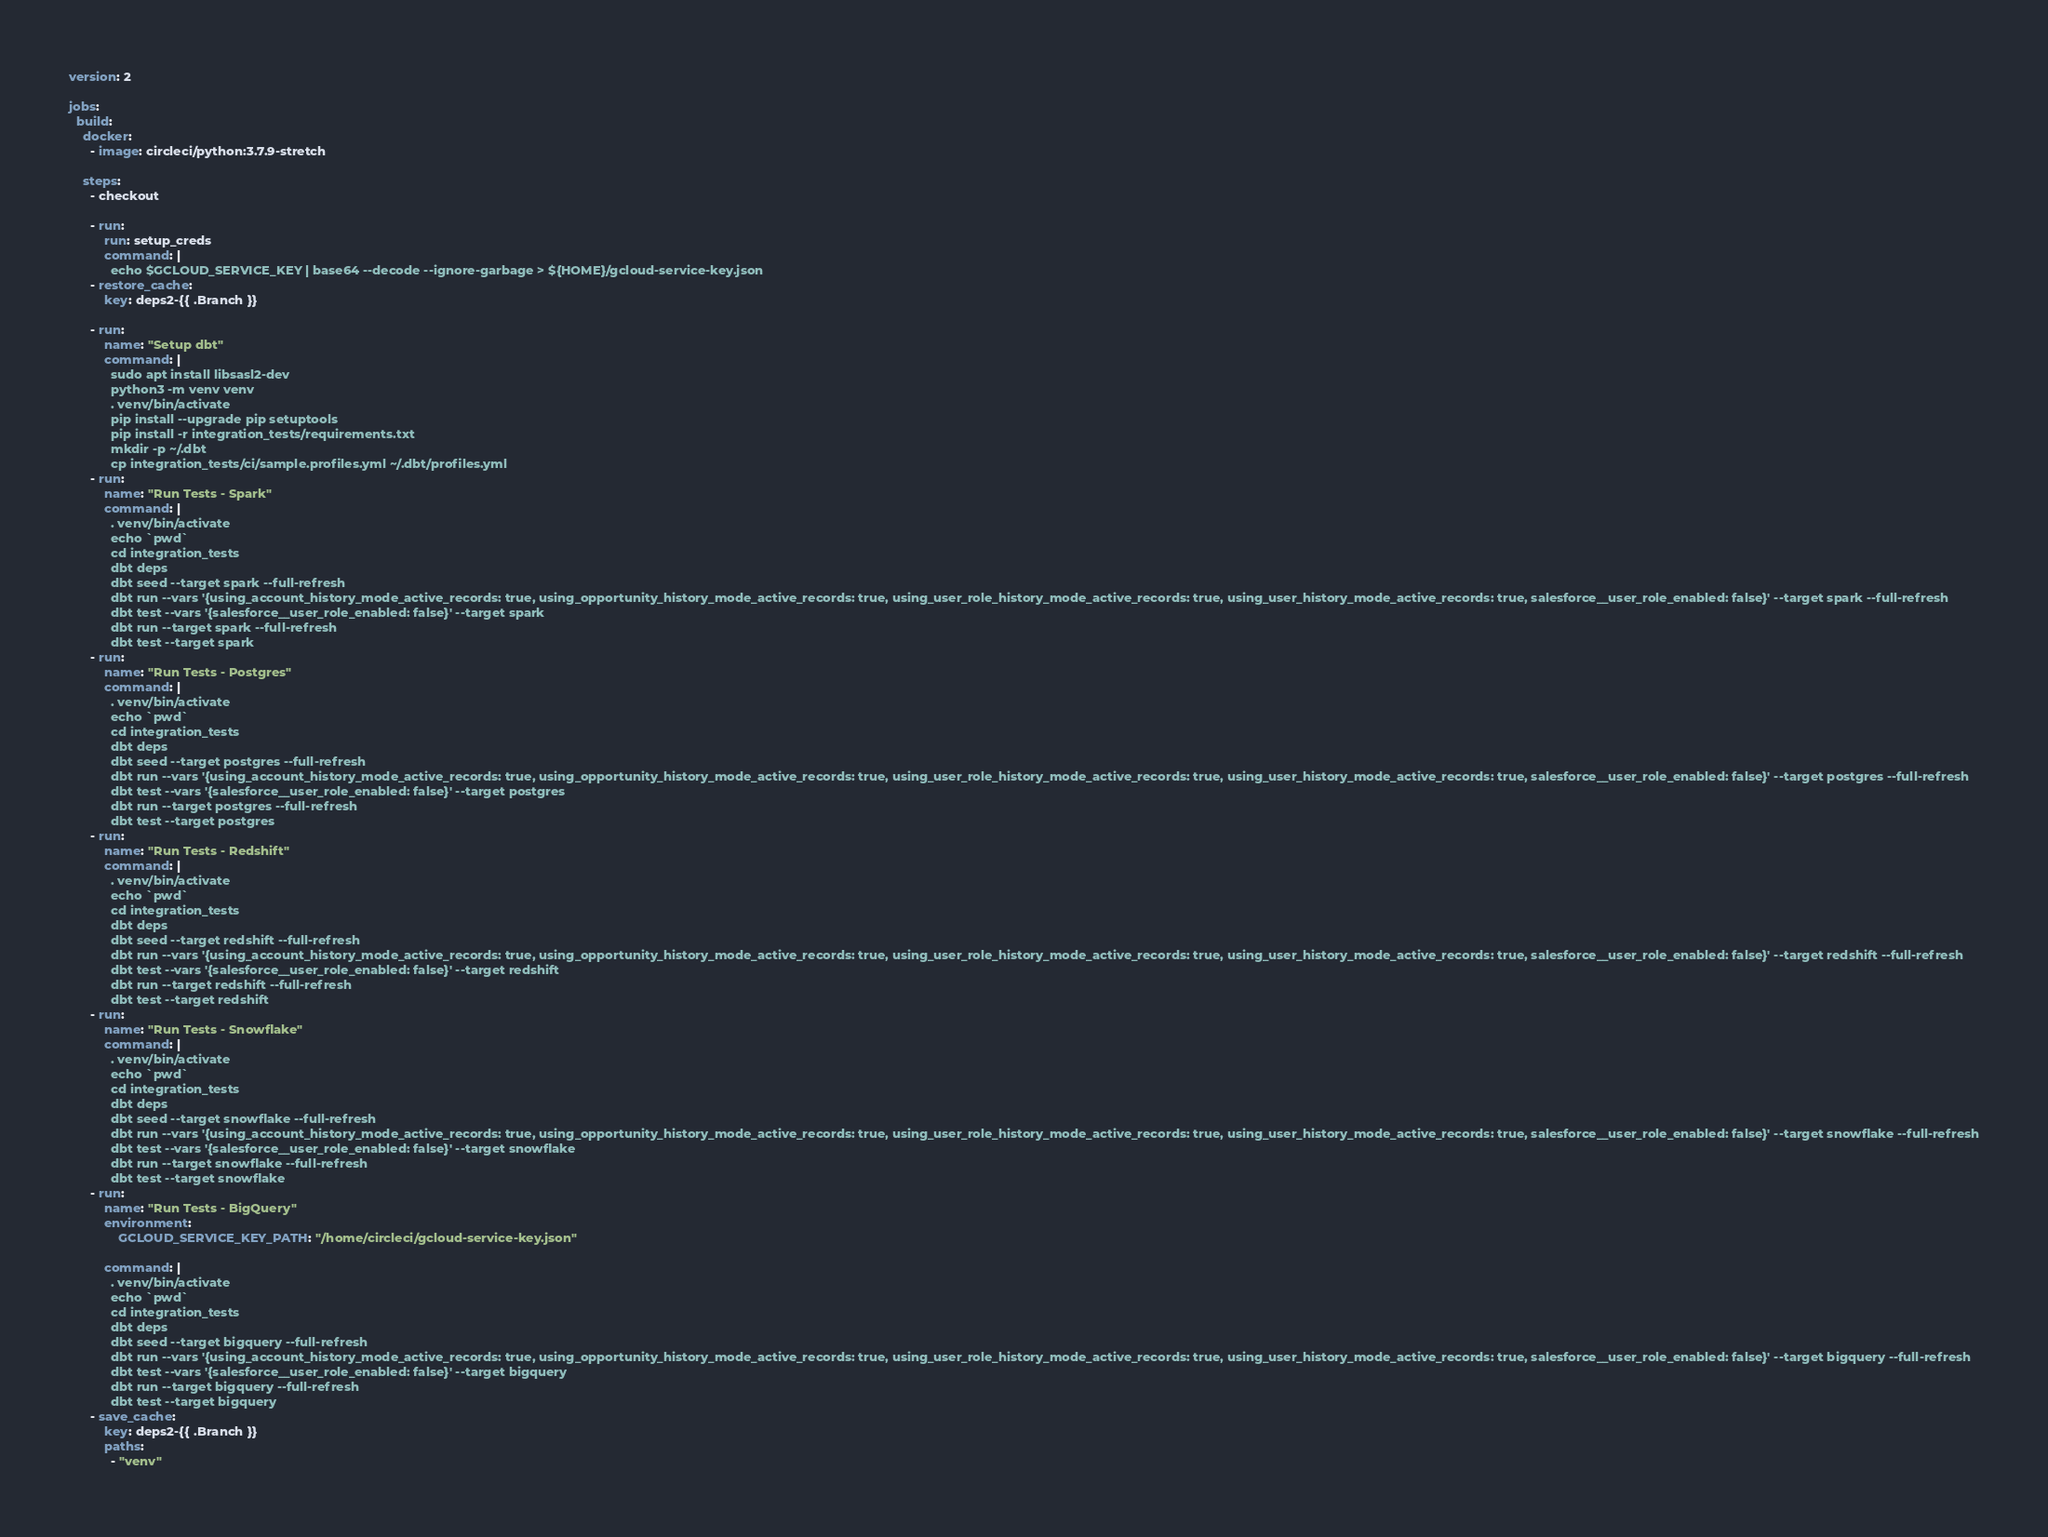Convert code to text. <code><loc_0><loc_0><loc_500><loc_500><_YAML_>version: 2

jobs:
  build:
    docker:
      - image: circleci/python:3.7.9-stretch

    steps:
      - checkout

      - run:
          run: setup_creds
          command: |
            echo $GCLOUD_SERVICE_KEY | base64 --decode --ignore-garbage > ${HOME}/gcloud-service-key.json
      - restore_cache:
          key: deps2-{{ .Branch }}

      - run:
          name: "Setup dbt"
          command: |
            sudo apt install libsasl2-dev
            python3 -m venv venv
            . venv/bin/activate
            pip install --upgrade pip setuptools
            pip install -r integration_tests/requirements.txt
            mkdir -p ~/.dbt
            cp integration_tests/ci/sample.profiles.yml ~/.dbt/profiles.yml
      - run:
          name: "Run Tests - Spark"
          command: |
            . venv/bin/activate
            echo `pwd`
            cd integration_tests
            dbt deps
            dbt seed --target spark --full-refresh
            dbt run --vars '{using_account_history_mode_active_records: true, using_opportunity_history_mode_active_records: true, using_user_role_history_mode_active_records: true, using_user_history_mode_active_records: true, salesforce__user_role_enabled: false}' --target spark --full-refresh
            dbt test --vars '{salesforce__user_role_enabled: false}' --target spark
            dbt run --target spark --full-refresh
            dbt test --target spark
      - run:
          name: "Run Tests - Postgres"
          command: |
            . venv/bin/activate
            echo `pwd`
            cd integration_tests
            dbt deps
            dbt seed --target postgres --full-refresh
            dbt run --vars '{using_account_history_mode_active_records: true, using_opportunity_history_mode_active_records: true, using_user_role_history_mode_active_records: true, using_user_history_mode_active_records: true, salesforce__user_role_enabled: false}' --target postgres --full-refresh
            dbt test --vars '{salesforce__user_role_enabled: false}' --target postgres
            dbt run --target postgres --full-refresh
            dbt test --target postgres
      - run:
          name: "Run Tests - Redshift"
          command: |
            . venv/bin/activate
            echo `pwd`
            cd integration_tests
            dbt deps
            dbt seed --target redshift --full-refresh
            dbt run --vars '{using_account_history_mode_active_records: true, using_opportunity_history_mode_active_records: true, using_user_role_history_mode_active_records: true, using_user_history_mode_active_records: true, salesforce__user_role_enabled: false}' --target redshift --full-refresh
            dbt test --vars '{salesforce__user_role_enabled: false}' --target redshift
            dbt run --target redshift --full-refresh
            dbt test --target redshift
      - run:
          name: "Run Tests - Snowflake"
          command: |
            . venv/bin/activate
            echo `pwd`
            cd integration_tests
            dbt deps
            dbt seed --target snowflake --full-refresh
            dbt run --vars '{using_account_history_mode_active_records: true, using_opportunity_history_mode_active_records: true, using_user_role_history_mode_active_records: true, using_user_history_mode_active_records: true, salesforce__user_role_enabled: false}' --target snowflake --full-refresh
            dbt test --vars '{salesforce__user_role_enabled: false}' --target snowflake
            dbt run --target snowflake --full-refresh
            dbt test --target snowflake
      - run:
          name: "Run Tests - BigQuery"
          environment:
              GCLOUD_SERVICE_KEY_PATH: "/home/circleci/gcloud-service-key.json"

          command: |
            . venv/bin/activate
            echo `pwd`
            cd integration_tests
            dbt deps
            dbt seed --target bigquery --full-refresh
            dbt run --vars '{using_account_history_mode_active_records: true, using_opportunity_history_mode_active_records: true, using_user_role_history_mode_active_records: true, using_user_history_mode_active_records: true, salesforce__user_role_enabled: false}' --target bigquery --full-refresh
            dbt test --vars '{salesforce__user_role_enabled: false}' --target bigquery
            dbt run --target bigquery --full-refresh
            dbt test --target bigquery
      - save_cache:
          key: deps2-{{ .Branch }}
          paths:
            - "venv"</code> 